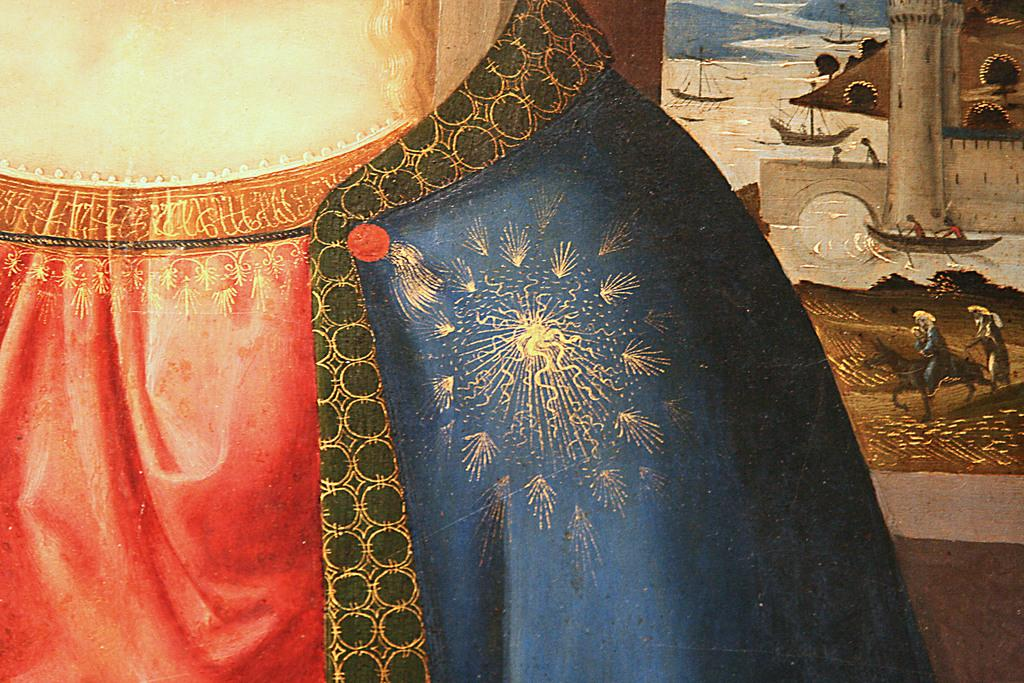What is the main subject of the drawing in the image? The drawing includes people, horses, water, buildings, and boats. Can you describe the setting of the drawing? The drawing includes water, buildings, and boats, which suggests a waterfront or coastal setting. What type of animals are included in the drawing? The drawing includes horses. Are there any man-made structures in the drawing? Yes, the drawing includes buildings. What type of soap is being used to clean the brake in the image? There is no soap or brake present in the image; it contains a drawing with various elements, including people, horses, water, buildings, and boats. 